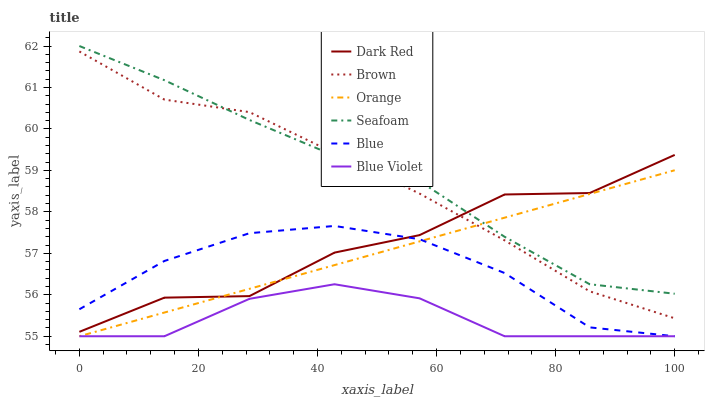Does Blue Violet have the minimum area under the curve?
Answer yes or no. Yes. Does Seafoam have the maximum area under the curve?
Answer yes or no. Yes. Does Brown have the minimum area under the curve?
Answer yes or no. No. Does Brown have the maximum area under the curve?
Answer yes or no. No. Is Orange the smoothest?
Answer yes or no. Yes. Is Dark Red the roughest?
Answer yes or no. Yes. Is Brown the smoothest?
Answer yes or no. No. Is Brown the roughest?
Answer yes or no. No. Does Brown have the lowest value?
Answer yes or no. No. Does Seafoam have the highest value?
Answer yes or no. Yes. Does Brown have the highest value?
Answer yes or no. No. Is Blue less than Seafoam?
Answer yes or no. Yes. Is Seafoam greater than Blue Violet?
Answer yes or no. Yes. Does Dark Red intersect Seafoam?
Answer yes or no. Yes. Is Dark Red less than Seafoam?
Answer yes or no. No. Is Dark Red greater than Seafoam?
Answer yes or no. No. Does Blue intersect Seafoam?
Answer yes or no. No. 